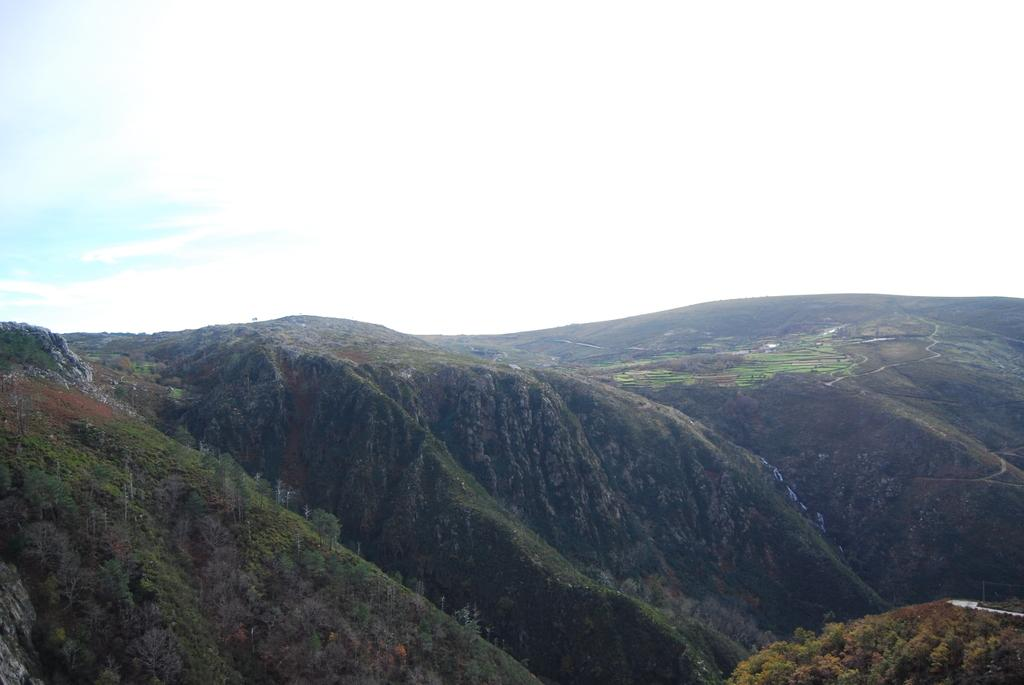What type of natural landscape is depicted in the image? The image features mountains and trees. How are the mountains and trees arranged in the image? The mountains and trees are arranged from left to right. What is the condition of the sky in the image? The sky is cloudy in the image. Can you see any elbows in the image? There are no elbows present in the image, as it features a natural landscape with mountains and trees. Is there any magic happening in the image? There is no magic depicted in the image; it shows a natural scene with mountains, trees, and a cloudy sky. 